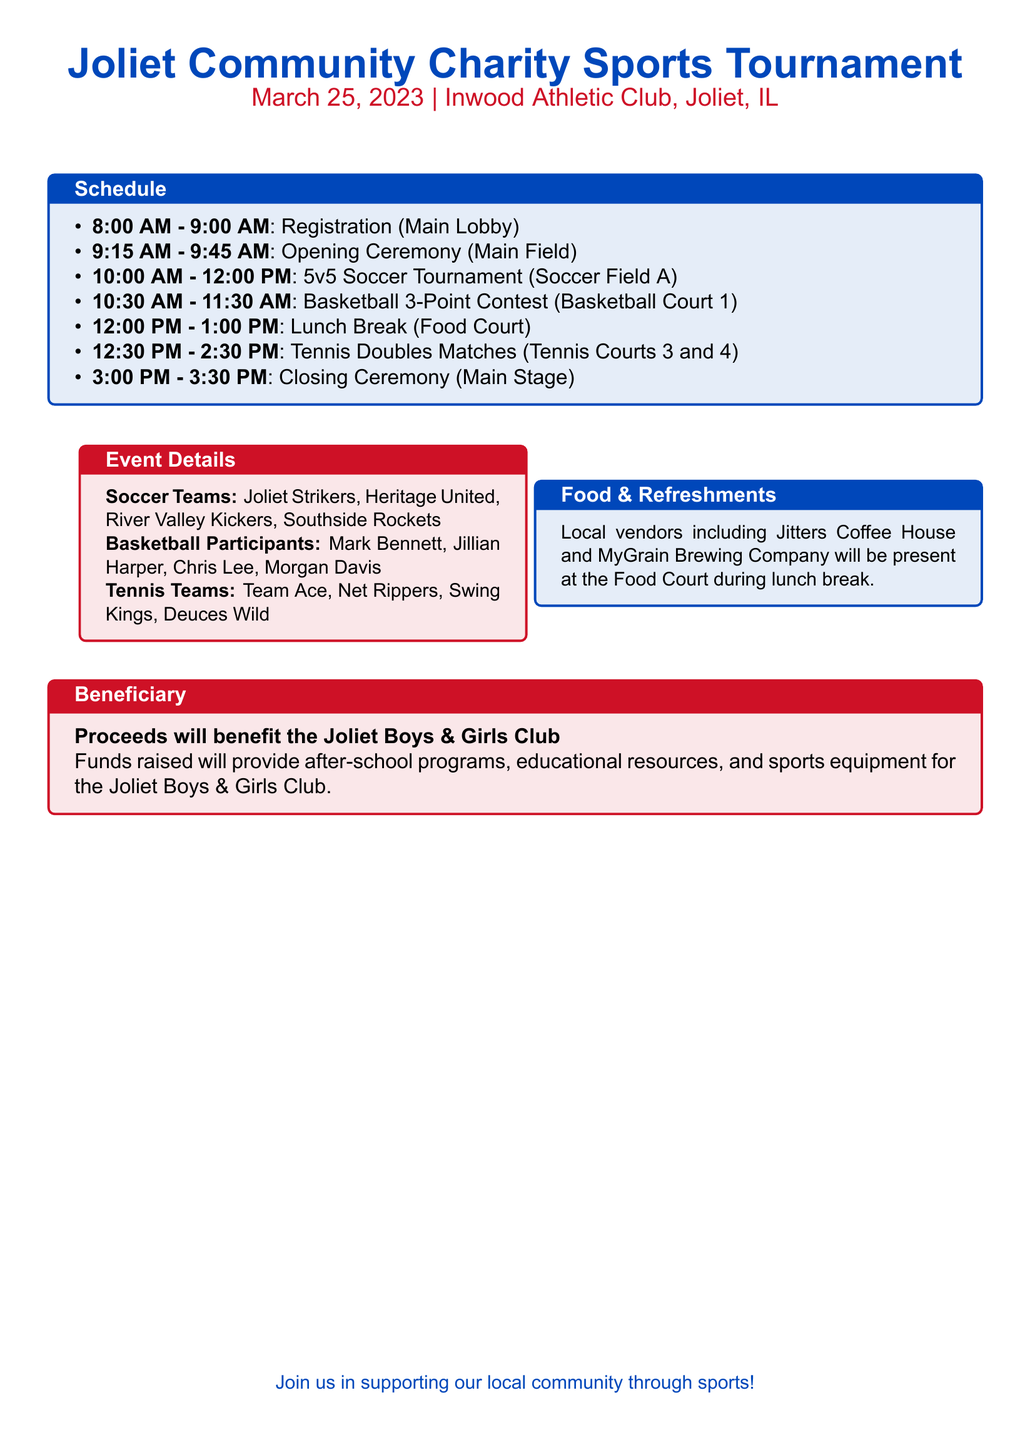What time does registration start? Registration starts at 8:00 AM according to the schedule.
Answer: 8:00 AM What is the venue for the tournament? The venue for the tournament is the Inwood Athletic Club, as mentioned at the top of the document.
Answer: Inwood Athletic Club Which teams are participating in the soccer tournament? The document lists the participating soccer teams: Joliet Strikers, Heritage United, River Valley Kickers, and Southside Rockets.
Answer: Joliet Strikers, Heritage United, River Valley Kickers, Southside Rockets When is the lunch break scheduled? The lunch break is scheduled from 12:00 PM to 1:00 PM as part of the schedule.
Answer: 12:00 PM - 1:00 PM What are the proceeds benefiting? The proceeds will benefit the Joliet Boys & Girls Club, which is stated in the beneficiary section.
Answer: Joliet Boys & Girls Club How many basketball players are mentioned? The event details list four basketball participants, indicating the number of players involved.
Answer: Four What types of food vendors will be present? Local vendors include Jitters Coffee House and MyGrain Brewing Company, which are mentioned under food & refreshments.
Answer: Jitters Coffee House and MyGrain Brewing Company What time does the closing ceremony start? The closing ceremony is scheduled to start at 3:00 PM according to the itinerary.
Answer: 3:00 PM What is the date of the event? The event is scheduled for March 25, 2023, as specified in the document.
Answer: March 25, 2023 